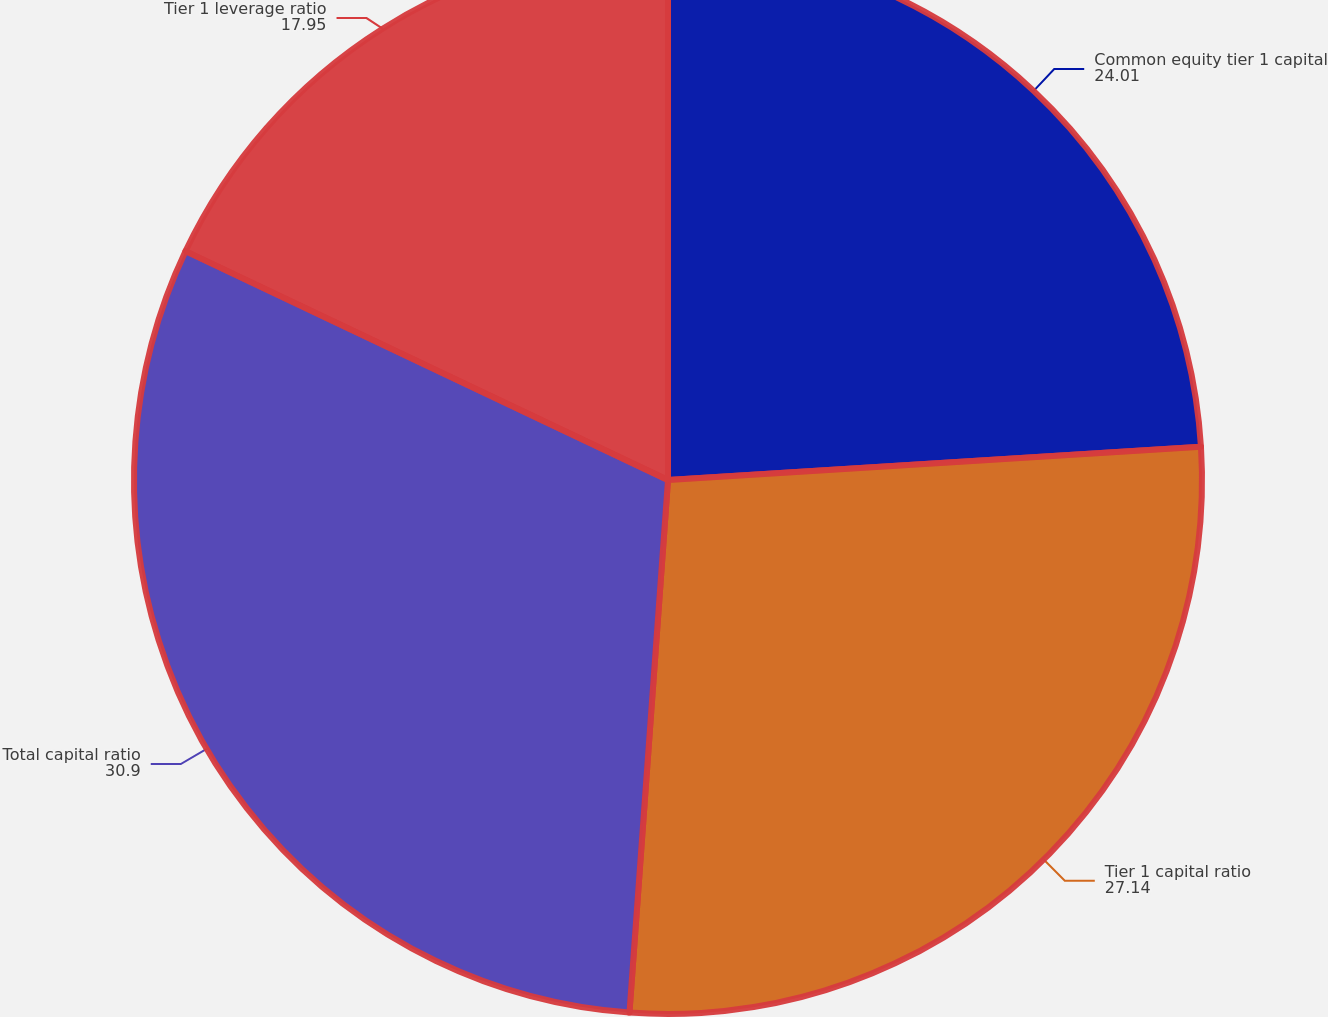Convert chart. <chart><loc_0><loc_0><loc_500><loc_500><pie_chart><fcel>Common equity tier 1 capital<fcel>Tier 1 capital ratio<fcel>Total capital ratio<fcel>Tier 1 leverage ratio<nl><fcel>24.01%<fcel>27.14%<fcel>30.9%<fcel>17.95%<nl></chart> 